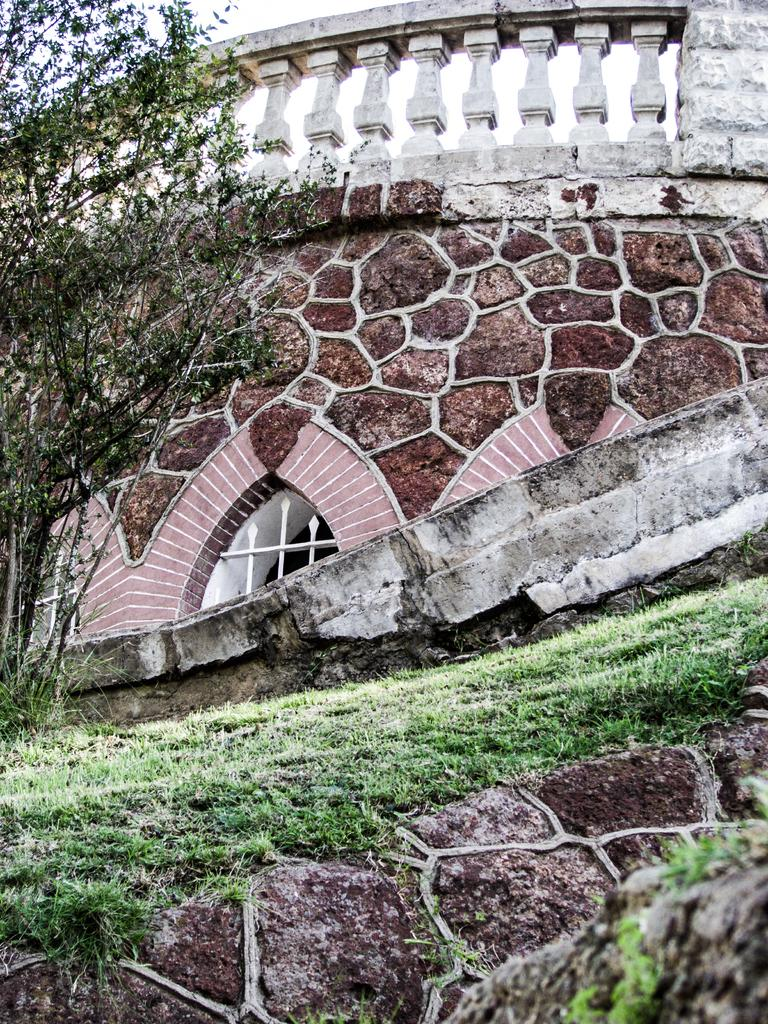What type of vegetation is on the left side of the image? There are trees on the left side of the image. What is the main subject in the middle of the image? There is a construction site in the middle of the image. What type of ground cover is at the bottom of the image? There is grass at the bottom of the image. Can you see a pencil being used at the construction site in the image? There is no pencil visible in the image, and it is not mentioned in the provided facts. 